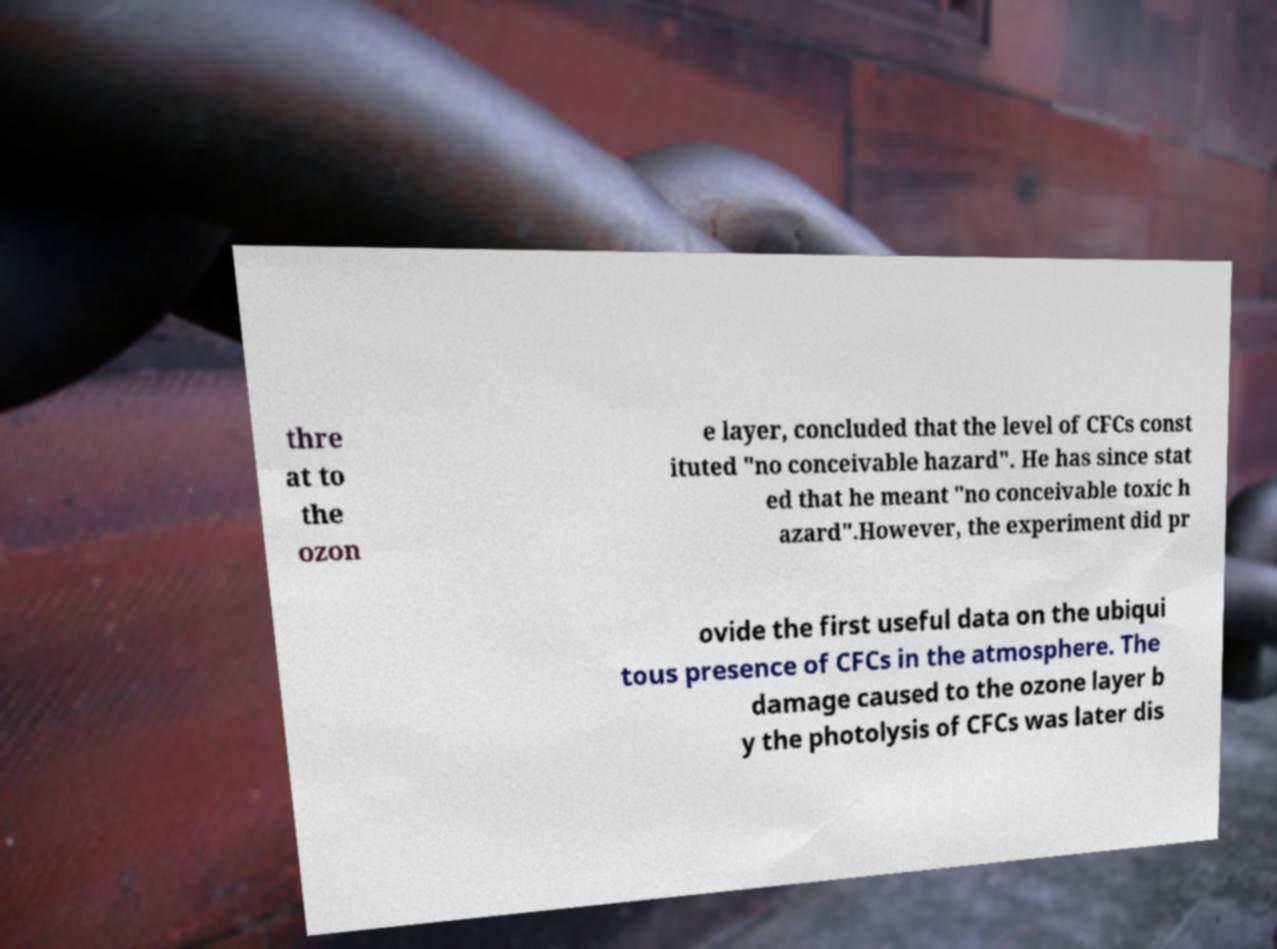Can you accurately transcribe the text from the provided image for me? thre at to the ozon e layer, concluded that the level of CFCs const ituted "no conceivable hazard". He has since stat ed that he meant "no conceivable toxic h azard".However, the experiment did pr ovide the first useful data on the ubiqui tous presence of CFCs in the atmosphere. The damage caused to the ozone layer b y the photolysis of CFCs was later dis 